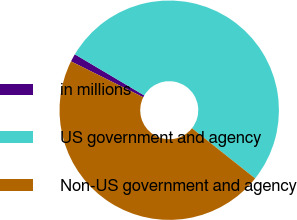Convert chart to OTSL. <chart><loc_0><loc_0><loc_500><loc_500><pie_chart><fcel>in millions<fcel>US government and agency<fcel>Non-US government and agency<nl><fcel>1.17%<fcel>52.17%<fcel>46.66%<nl></chart> 